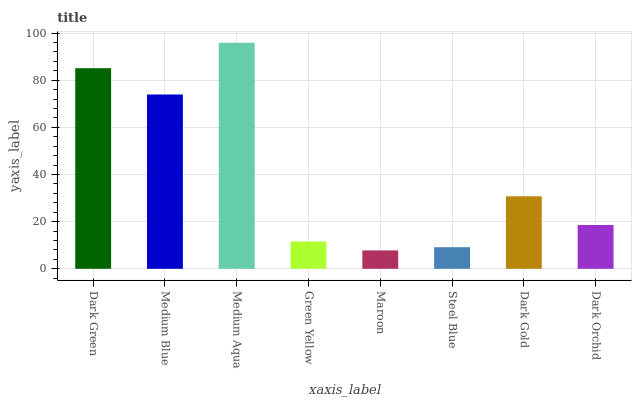Is Maroon the minimum?
Answer yes or no. Yes. Is Medium Aqua the maximum?
Answer yes or no. Yes. Is Medium Blue the minimum?
Answer yes or no. No. Is Medium Blue the maximum?
Answer yes or no. No. Is Dark Green greater than Medium Blue?
Answer yes or no. Yes. Is Medium Blue less than Dark Green?
Answer yes or no. Yes. Is Medium Blue greater than Dark Green?
Answer yes or no. No. Is Dark Green less than Medium Blue?
Answer yes or no. No. Is Dark Gold the high median?
Answer yes or no. Yes. Is Dark Orchid the low median?
Answer yes or no. Yes. Is Medium Blue the high median?
Answer yes or no. No. Is Maroon the low median?
Answer yes or no. No. 